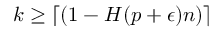Convert formula to latex. <formula><loc_0><loc_0><loc_500><loc_500>k \geq \lceil ( 1 - H ( p + \epsilon ) n ) \rceil</formula> 